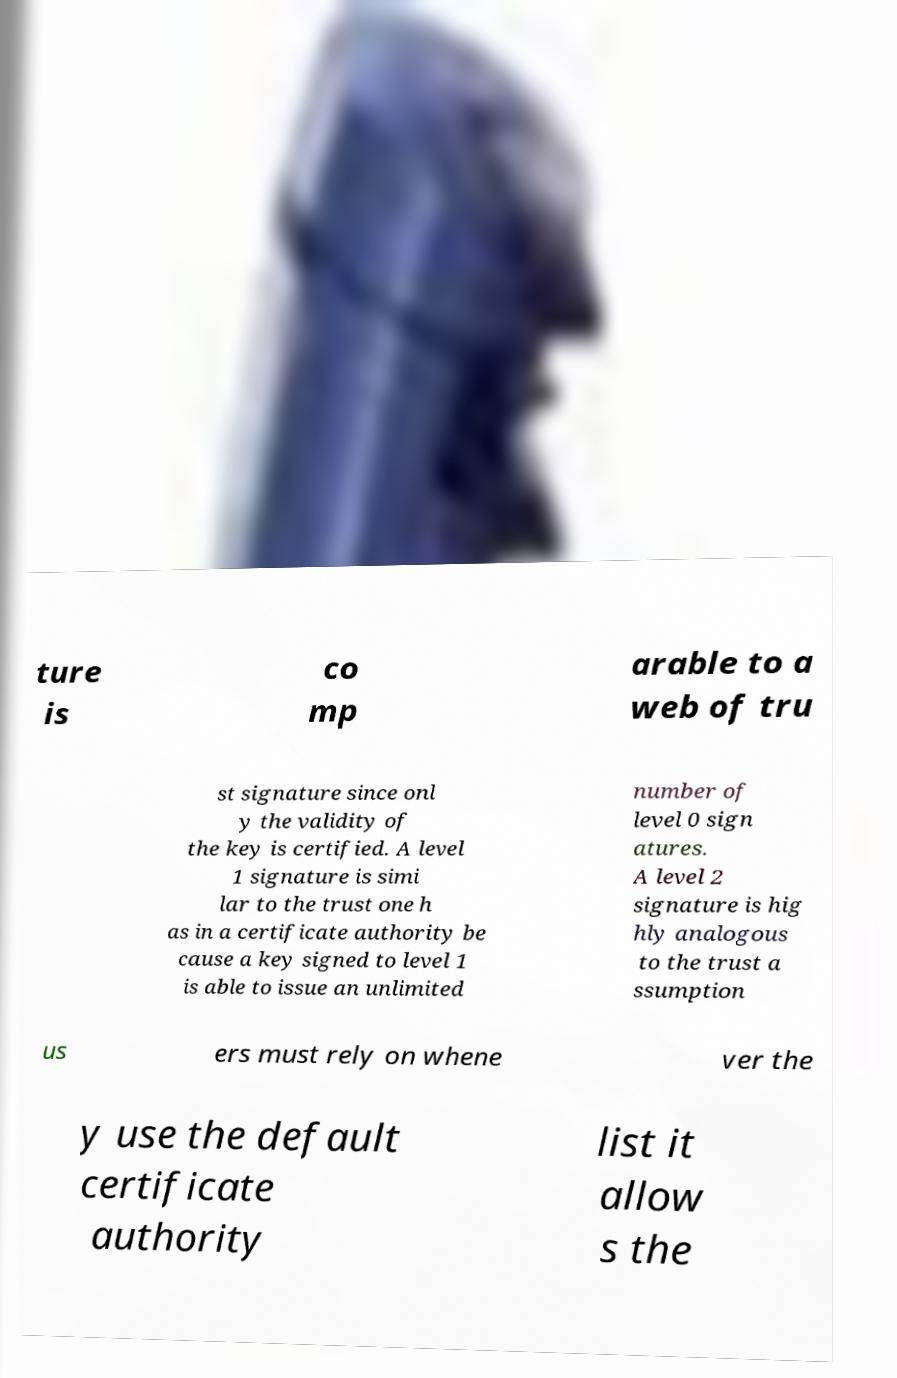Can you read and provide the text displayed in the image?This photo seems to have some interesting text. Can you extract and type it out for me? ture is co mp arable to a web of tru st signature since onl y the validity of the key is certified. A level 1 signature is simi lar to the trust one h as in a certificate authority be cause a key signed to level 1 is able to issue an unlimited number of level 0 sign atures. A level 2 signature is hig hly analogous to the trust a ssumption us ers must rely on whene ver the y use the default certificate authority list it allow s the 